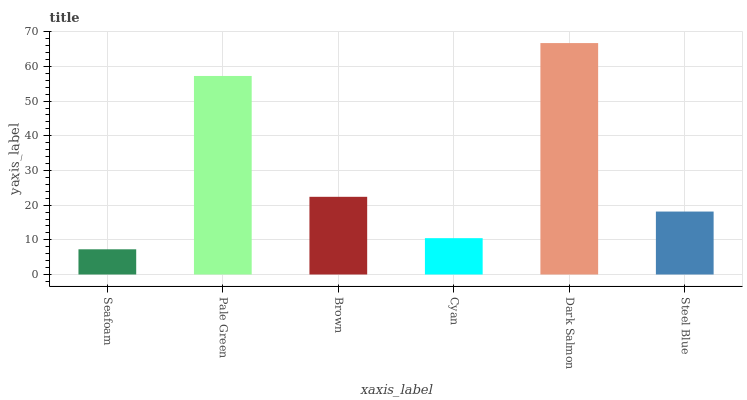Is Seafoam the minimum?
Answer yes or no. Yes. Is Dark Salmon the maximum?
Answer yes or no. Yes. Is Pale Green the minimum?
Answer yes or no. No. Is Pale Green the maximum?
Answer yes or no. No. Is Pale Green greater than Seafoam?
Answer yes or no. Yes. Is Seafoam less than Pale Green?
Answer yes or no. Yes. Is Seafoam greater than Pale Green?
Answer yes or no. No. Is Pale Green less than Seafoam?
Answer yes or no. No. Is Brown the high median?
Answer yes or no. Yes. Is Steel Blue the low median?
Answer yes or no. Yes. Is Steel Blue the high median?
Answer yes or no. No. Is Brown the low median?
Answer yes or no. No. 